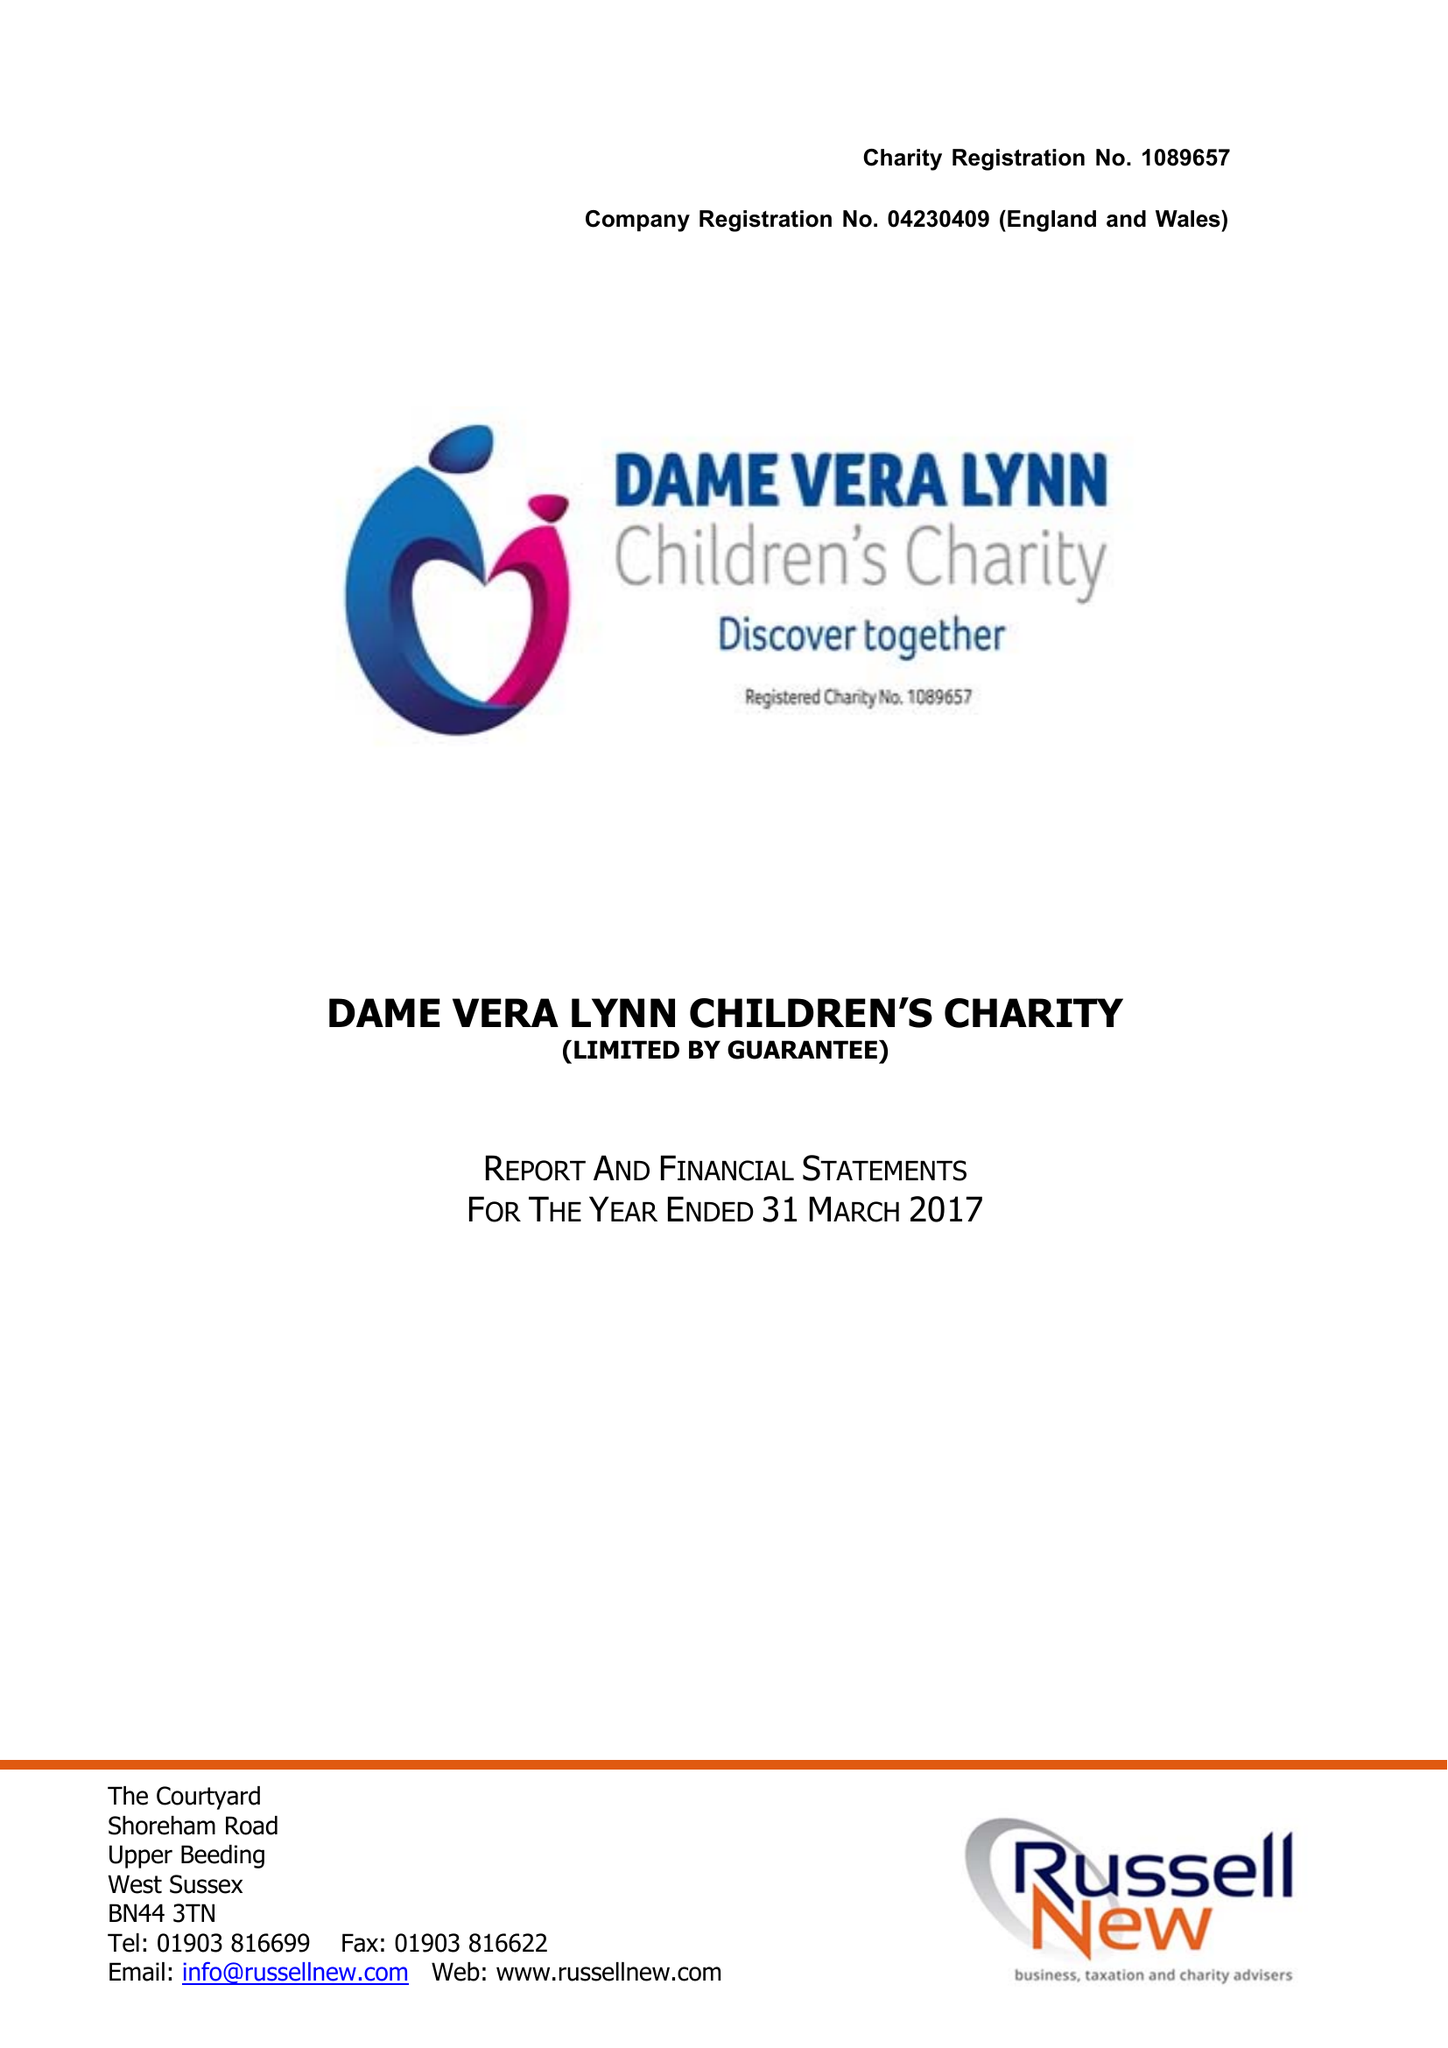What is the value for the income_annually_in_british_pounds?
Answer the question using a single word or phrase. 444585.00 